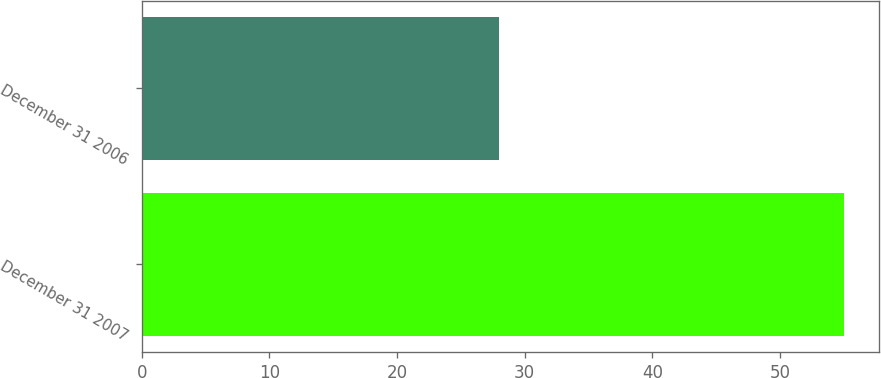Convert chart. <chart><loc_0><loc_0><loc_500><loc_500><bar_chart><fcel>December 31 2007<fcel>December 31 2006<nl><fcel>55<fcel>28<nl></chart> 